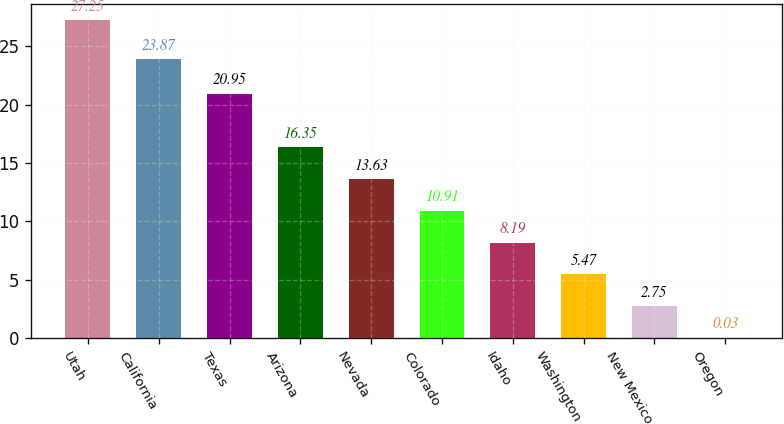Convert chart. <chart><loc_0><loc_0><loc_500><loc_500><bar_chart><fcel>Utah<fcel>California<fcel>Texas<fcel>Arizona<fcel>Nevada<fcel>Colorado<fcel>Idaho<fcel>Washington<fcel>New Mexico<fcel>Oregon<nl><fcel>27.25<fcel>23.87<fcel>20.95<fcel>16.35<fcel>13.63<fcel>10.91<fcel>8.19<fcel>5.47<fcel>2.75<fcel>0.03<nl></chart> 